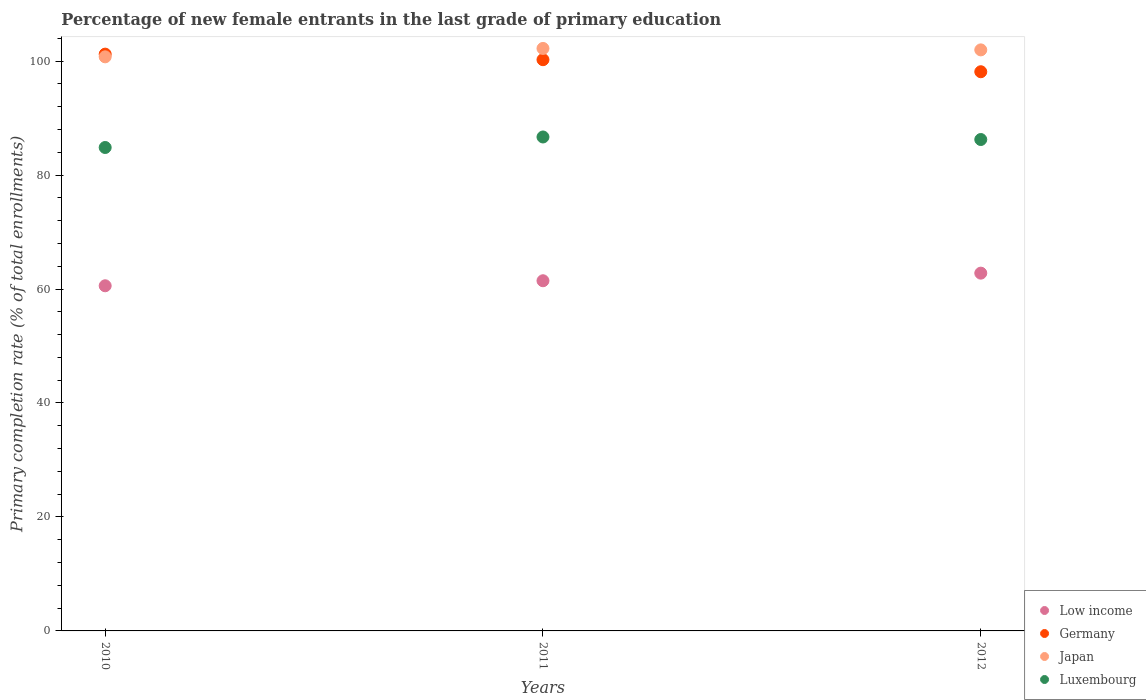How many different coloured dotlines are there?
Keep it short and to the point. 4. What is the percentage of new female entrants in Luxembourg in 2011?
Give a very brief answer. 86.68. Across all years, what is the maximum percentage of new female entrants in Japan?
Offer a terse response. 102.21. Across all years, what is the minimum percentage of new female entrants in Japan?
Keep it short and to the point. 100.74. What is the total percentage of new female entrants in Japan in the graph?
Ensure brevity in your answer.  304.92. What is the difference between the percentage of new female entrants in Japan in 2010 and that in 2012?
Your answer should be very brief. -1.22. What is the difference between the percentage of new female entrants in Germany in 2011 and the percentage of new female entrants in Luxembourg in 2010?
Your response must be concise. 15.41. What is the average percentage of new female entrants in Low income per year?
Provide a short and direct response. 61.6. In the year 2010, what is the difference between the percentage of new female entrants in Luxembourg and percentage of new female entrants in Germany?
Make the answer very short. -16.39. What is the ratio of the percentage of new female entrants in Germany in 2010 to that in 2011?
Provide a succinct answer. 1.01. Is the percentage of new female entrants in Luxembourg in 2010 less than that in 2012?
Keep it short and to the point. Yes. Is the difference between the percentage of new female entrants in Luxembourg in 2010 and 2012 greater than the difference between the percentage of new female entrants in Germany in 2010 and 2012?
Your answer should be compact. No. What is the difference between the highest and the second highest percentage of new female entrants in Luxembourg?
Offer a terse response. 0.45. What is the difference between the highest and the lowest percentage of new female entrants in Low income?
Offer a very short reply. 2.22. In how many years, is the percentage of new female entrants in Low income greater than the average percentage of new female entrants in Low income taken over all years?
Ensure brevity in your answer.  1. What is the difference between two consecutive major ticks on the Y-axis?
Make the answer very short. 20. Does the graph contain any zero values?
Give a very brief answer. No. Does the graph contain grids?
Provide a short and direct response. No. How many legend labels are there?
Ensure brevity in your answer.  4. What is the title of the graph?
Your answer should be very brief. Percentage of new female entrants in the last grade of primary education. What is the label or title of the Y-axis?
Your response must be concise. Primary completion rate (% of total enrollments). What is the Primary completion rate (% of total enrollments) in Low income in 2010?
Offer a terse response. 60.57. What is the Primary completion rate (% of total enrollments) in Germany in 2010?
Provide a succinct answer. 101.22. What is the Primary completion rate (% of total enrollments) of Japan in 2010?
Give a very brief answer. 100.74. What is the Primary completion rate (% of total enrollments) in Luxembourg in 2010?
Your answer should be very brief. 84.83. What is the Primary completion rate (% of total enrollments) in Low income in 2011?
Your response must be concise. 61.45. What is the Primary completion rate (% of total enrollments) in Germany in 2011?
Your answer should be very brief. 100.24. What is the Primary completion rate (% of total enrollments) in Japan in 2011?
Provide a succinct answer. 102.21. What is the Primary completion rate (% of total enrollments) of Luxembourg in 2011?
Make the answer very short. 86.68. What is the Primary completion rate (% of total enrollments) in Low income in 2012?
Offer a terse response. 62.78. What is the Primary completion rate (% of total enrollments) in Germany in 2012?
Offer a very short reply. 98.13. What is the Primary completion rate (% of total enrollments) of Japan in 2012?
Provide a short and direct response. 101.96. What is the Primary completion rate (% of total enrollments) in Luxembourg in 2012?
Make the answer very short. 86.23. Across all years, what is the maximum Primary completion rate (% of total enrollments) of Low income?
Your answer should be compact. 62.78. Across all years, what is the maximum Primary completion rate (% of total enrollments) of Germany?
Make the answer very short. 101.22. Across all years, what is the maximum Primary completion rate (% of total enrollments) of Japan?
Your response must be concise. 102.21. Across all years, what is the maximum Primary completion rate (% of total enrollments) of Luxembourg?
Provide a short and direct response. 86.68. Across all years, what is the minimum Primary completion rate (% of total enrollments) of Low income?
Your response must be concise. 60.57. Across all years, what is the minimum Primary completion rate (% of total enrollments) of Germany?
Your response must be concise. 98.13. Across all years, what is the minimum Primary completion rate (% of total enrollments) of Japan?
Provide a succinct answer. 100.74. Across all years, what is the minimum Primary completion rate (% of total enrollments) of Luxembourg?
Keep it short and to the point. 84.83. What is the total Primary completion rate (% of total enrollments) of Low income in the graph?
Offer a very short reply. 184.8. What is the total Primary completion rate (% of total enrollments) in Germany in the graph?
Your answer should be compact. 299.58. What is the total Primary completion rate (% of total enrollments) of Japan in the graph?
Give a very brief answer. 304.92. What is the total Primary completion rate (% of total enrollments) in Luxembourg in the graph?
Ensure brevity in your answer.  257.74. What is the difference between the Primary completion rate (% of total enrollments) in Low income in 2010 and that in 2011?
Your answer should be very brief. -0.88. What is the difference between the Primary completion rate (% of total enrollments) in Germany in 2010 and that in 2011?
Provide a succinct answer. 0.98. What is the difference between the Primary completion rate (% of total enrollments) of Japan in 2010 and that in 2011?
Offer a terse response. -1.47. What is the difference between the Primary completion rate (% of total enrollments) in Luxembourg in 2010 and that in 2011?
Provide a succinct answer. -1.85. What is the difference between the Primary completion rate (% of total enrollments) in Low income in 2010 and that in 2012?
Your answer should be very brief. -2.22. What is the difference between the Primary completion rate (% of total enrollments) in Germany in 2010 and that in 2012?
Give a very brief answer. 3.09. What is the difference between the Primary completion rate (% of total enrollments) in Japan in 2010 and that in 2012?
Your answer should be very brief. -1.22. What is the difference between the Primary completion rate (% of total enrollments) in Luxembourg in 2010 and that in 2012?
Provide a short and direct response. -1.4. What is the difference between the Primary completion rate (% of total enrollments) in Low income in 2011 and that in 2012?
Provide a short and direct response. -1.33. What is the difference between the Primary completion rate (% of total enrollments) of Germany in 2011 and that in 2012?
Offer a terse response. 2.11. What is the difference between the Primary completion rate (% of total enrollments) in Japan in 2011 and that in 2012?
Give a very brief answer. 0.25. What is the difference between the Primary completion rate (% of total enrollments) of Luxembourg in 2011 and that in 2012?
Offer a terse response. 0.45. What is the difference between the Primary completion rate (% of total enrollments) in Low income in 2010 and the Primary completion rate (% of total enrollments) in Germany in 2011?
Your answer should be compact. -39.67. What is the difference between the Primary completion rate (% of total enrollments) of Low income in 2010 and the Primary completion rate (% of total enrollments) of Japan in 2011?
Give a very brief answer. -41.65. What is the difference between the Primary completion rate (% of total enrollments) of Low income in 2010 and the Primary completion rate (% of total enrollments) of Luxembourg in 2011?
Ensure brevity in your answer.  -26.11. What is the difference between the Primary completion rate (% of total enrollments) in Germany in 2010 and the Primary completion rate (% of total enrollments) in Japan in 2011?
Provide a short and direct response. -1. What is the difference between the Primary completion rate (% of total enrollments) of Germany in 2010 and the Primary completion rate (% of total enrollments) of Luxembourg in 2011?
Keep it short and to the point. 14.54. What is the difference between the Primary completion rate (% of total enrollments) of Japan in 2010 and the Primary completion rate (% of total enrollments) of Luxembourg in 2011?
Keep it short and to the point. 14.06. What is the difference between the Primary completion rate (% of total enrollments) in Low income in 2010 and the Primary completion rate (% of total enrollments) in Germany in 2012?
Provide a succinct answer. -37.56. What is the difference between the Primary completion rate (% of total enrollments) in Low income in 2010 and the Primary completion rate (% of total enrollments) in Japan in 2012?
Your answer should be compact. -41.4. What is the difference between the Primary completion rate (% of total enrollments) in Low income in 2010 and the Primary completion rate (% of total enrollments) in Luxembourg in 2012?
Ensure brevity in your answer.  -25.67. What is the difference between the Primary completion rate (% of total enrollments) of Germany in 2010 and the Primary completion rate (% of total enrollments) of Japan in 2012?
Your answer should be compact. -0.75. What is the difference between the Primary completion rate (% of total enrollments) of Germany in 2010 and the Primary completion rate (% of total enrollments) of Luxembourg in 2012?
Your response must be concise. 14.98. What is the difference between the Primary completion rate (% of total enrollments) of Japan in 2010 and the Primary completion rate (% of total enrollments) of Luxembourg in 2012?
Provide a succinct answer. 14.51. What is the difference between the Primary completion rate (% of total enrollments) of Low income in 2011 and the Primary completion rate (% of total enrollments) of Germany in 2012?
Your answer should be compact. -36.68. What is the difference between the Primary completion rate (% of total enrollments) in Low income in 2011 and the Primary completion rate (% of total enrollments) in Japan in 2012?
Provide a short and direct response. -40.51. What is the difference between the Primary completion rate (% of total enrollments) in Low income in 2011 and the Primary completion rate (% of total enrollments) in Luxembourg in 2012?
Make the answer very short. -24.78. What is the difference between the Primary completion rate (% of total enrollments) in Germany in 2011 and the Primary completion rate (% of total enrollments) in Japan in 2012?
Offer a terse response. -1.72. What is the difference between the Primary completion rate (% of total enrollments) of Germany in 2011 and the Primary completion rate (% of total enrollments) of Luxembourg in 2012?
Offer a terse response. 14.01. What is the difference between the Primary completion rate (% of total enrollments) of Japan in 2011 and the Primary completion rate (% of total enrollments) of Luxembourg in 2012?
Give a very brief answer. 15.98. What is the average Primary completion rate (% of total enrollments) in Low income per year?
Offer a terse response. 61.6. What is the average Primary completion rate (% of total enrollments) in Germany per year?
Provide a short and direct response. 99.86. What is the average Primary completion rate (% of total enrollments) of Japan per year?
Your answer should be very brief. 101.64. What is the average Primary completion rate (% of total enrollments) of Luxembourg per year?
Offer a very short reply. 85.91. In the year 2010, what is the difference between the Primary completion rate (% of total enrollments) of Low income and Primary completion rate (% of total enrollments) of Germany?
Keep it short and to the point. -40.65. In the year 2010, what is the difference between the Primary completion rate (% of total enrollments) in Low income and Primary completion rate (% of total enrollments) in Japan?
Your response must be concise. -40.17. In the year 2010, what is the difference between the Primary completion rate (% of total enrollments) of Low income and Primary completion rate (% of total enrollments) of Luxembourg?
Keep it short and to the point. -24.26. In the year 2010, what is the difference between the Primary completion rate (% of total enrollments) in Germany and Primary completion rate (% of total enrollments) in Japan?
Your response must be concise. 0.47. In the year 2010, what is the difference between the Primary completion rate (% of total enrollments) in Germany and Primary completion rate (% of total enrollments) in Luxembourg?
Your answer should be compact. 16.39. In the year 2010, what is the difference between the Primary completion rate (% of total enrollments) in Japan and Primary completion rate (% of total enrollments) in Luxembourg?
Keep it short and to the point. 15.91. In the year 2011, what is the difference between the Primary completion rate (% of total enrollments) in Low income and Primary completion rate (% of total enrollments) in Germany?
Make the answer very short. -38.79. In the year 2011, what is the difference between the Primary completion rate (% of total enrollments) of Low income and Primary completion rate (% of total enrollments) of Japan?
Ensure brevity in your answer.  -40.77. In the year 2011, what is the difference between the Primary completion rate (% of total enrollments) in Low income and Primary completion rate (% of total enrollments) in Luxembourg?
Your answer should be compact. -25.23. In the year 2011, what is the difference between the Primary completion rate (% of total enrollments) of Germany and Primary completion rate (% of total enrollments) of Japan?
Make the answer very short. -1.98. In the year 2011, what is the difference between the Primary completion rate (% of total enrollments) in Germany and Primary completion rate (% of total enrollments) in Luxembourg?
Offer a very short reply. 13.56. In the year 2011, what is the difference between the Primary completion rate (% of total enrollments) in Japan and Primary completion rate (% of total enrollments) in Luxembourg?
Offer a very short reply. 15.54. In the year 2012, what is the difference between the Primary completion rate (% of total enrollments) of Low income and Primary completion rate (% of total enrollments) of Germany?
Your response must be concise. -35.34. In the year 2012, what is the difference between the Primary completion rate (% of total enrollments) in Low income and Primary completion rate (% of total enrollments) in Japan?
Your answer should be very brief. -39.18. In the year 2012, what is the difference between the Primary completion rate (% of total enrollments) in Low income and Primary completion rate (% of total enrollments) in Luxembourg?
Keep it short and to the point. -23.45. In the year 2012, what is the difference between the Primary completion rate (% of total enrollments) in Germany and Primary completion rate (% of total enrollments) in Japan?
Your answer should be compact. -3.84. In the year 2012, what is the difference between the Primary completion rate (% of total enrollments) in Germany and Primary completion rate (% of total enrollments) in Luxembourg?
Your answer should be very brief. 11.89. In the year 2012, what is the difference between the Primary completion rate (% of total enrollments) of Japan and Primary completion rate (% of total enrollments) of Luxembourg?
Give a very brief answer. 15.73. What is the ratio of the Primary completion rate (% of total enrollments) in Low income in 2010 to that in 2011?
Provide a short and direct response. 0.99. What is the ratio of the Primary completion rate (% of total enrollments) of Germany in 2010 to that in 2011?
Offer a terse response. 1.01. What is the ratio of the Primary completion rate (% of total enrollments) of Japan in 2010 to that in 2011?
Your answer should be compact. 0.99. What is the ratio of the Primary completion rate (% of total enrollments) of Luxembourg in 2010 to that in 2011?
Make the answer very short. 0.98. What is the ratio of the Primary completion rate (% of total enrollments) of Low income in 2010 to that in 2012?
Ensure brevity in your answer.  0.96. What is the ratio of the Primary completion rate (% of total enrollments) in Germany in 2010 to that in 2012?
Your response must be concise. 1.03. What is the ratio of the Primary completion rate (% of total enrollments) in Japan in 2010 to that in 2012?
Your answer should be very brief. 0.99. What is the ratio of the Primary completion rate (% of total enrollments) in Luxembourg in 2010 to that in 2012?
Offer a very short reply. 0.98. What is the ratio of the Primary completion rate (% of total enrollments) in Low income in 2011 to that in 2012?
Ensure brevity in your answer.  0.98. What is the ratio of the Primary completion rate (% of total enrollments) in Germany in 2011 to that in 2012?
Offer a terse response. 1.02. What is the ratio of the Primary completion rate (% of total enrollments) of Luxembourg in 2011 to that in 2012?
Offer a very short reply. 1.01. What is the difference between the highest and the second highest Primary completion rate (% of total enrollments) of Low income?
Your response must be concise. 1.33. What is the difference between the highest and the second highest Primary completion rate (% of total enrollments) in Germany?
Make the answer very short. 0.98. What is the difference between the highest and the second highest Primary completion rate (% of total enrollments) in Japan?
Provide a short and direct response. 0.25. What is the difference between the highest and the second highest Primary completion rate (% of total enrollments) of Luxembourg?
Make the answer very short. 0.45. What is the difference between the highest and the lowest Primary completion rate (% of total enrollments) of Low income?
Ensure brevity in your answer.  2.22. What is the difference between the highest and the lowest Primary completion rate (% of total enrollments) in Germany?
Your answer should be compact. 3.09. What is the difference between the highest and the lowest Primary completion rate (% of total enrollments) in Japan?
Your answer should be compact. 1.47. What is the difference between the highest and the lowest Primary completion rate (% of total enrollments) in Luxembourg?
Provide a succinct answer. 1.85. 